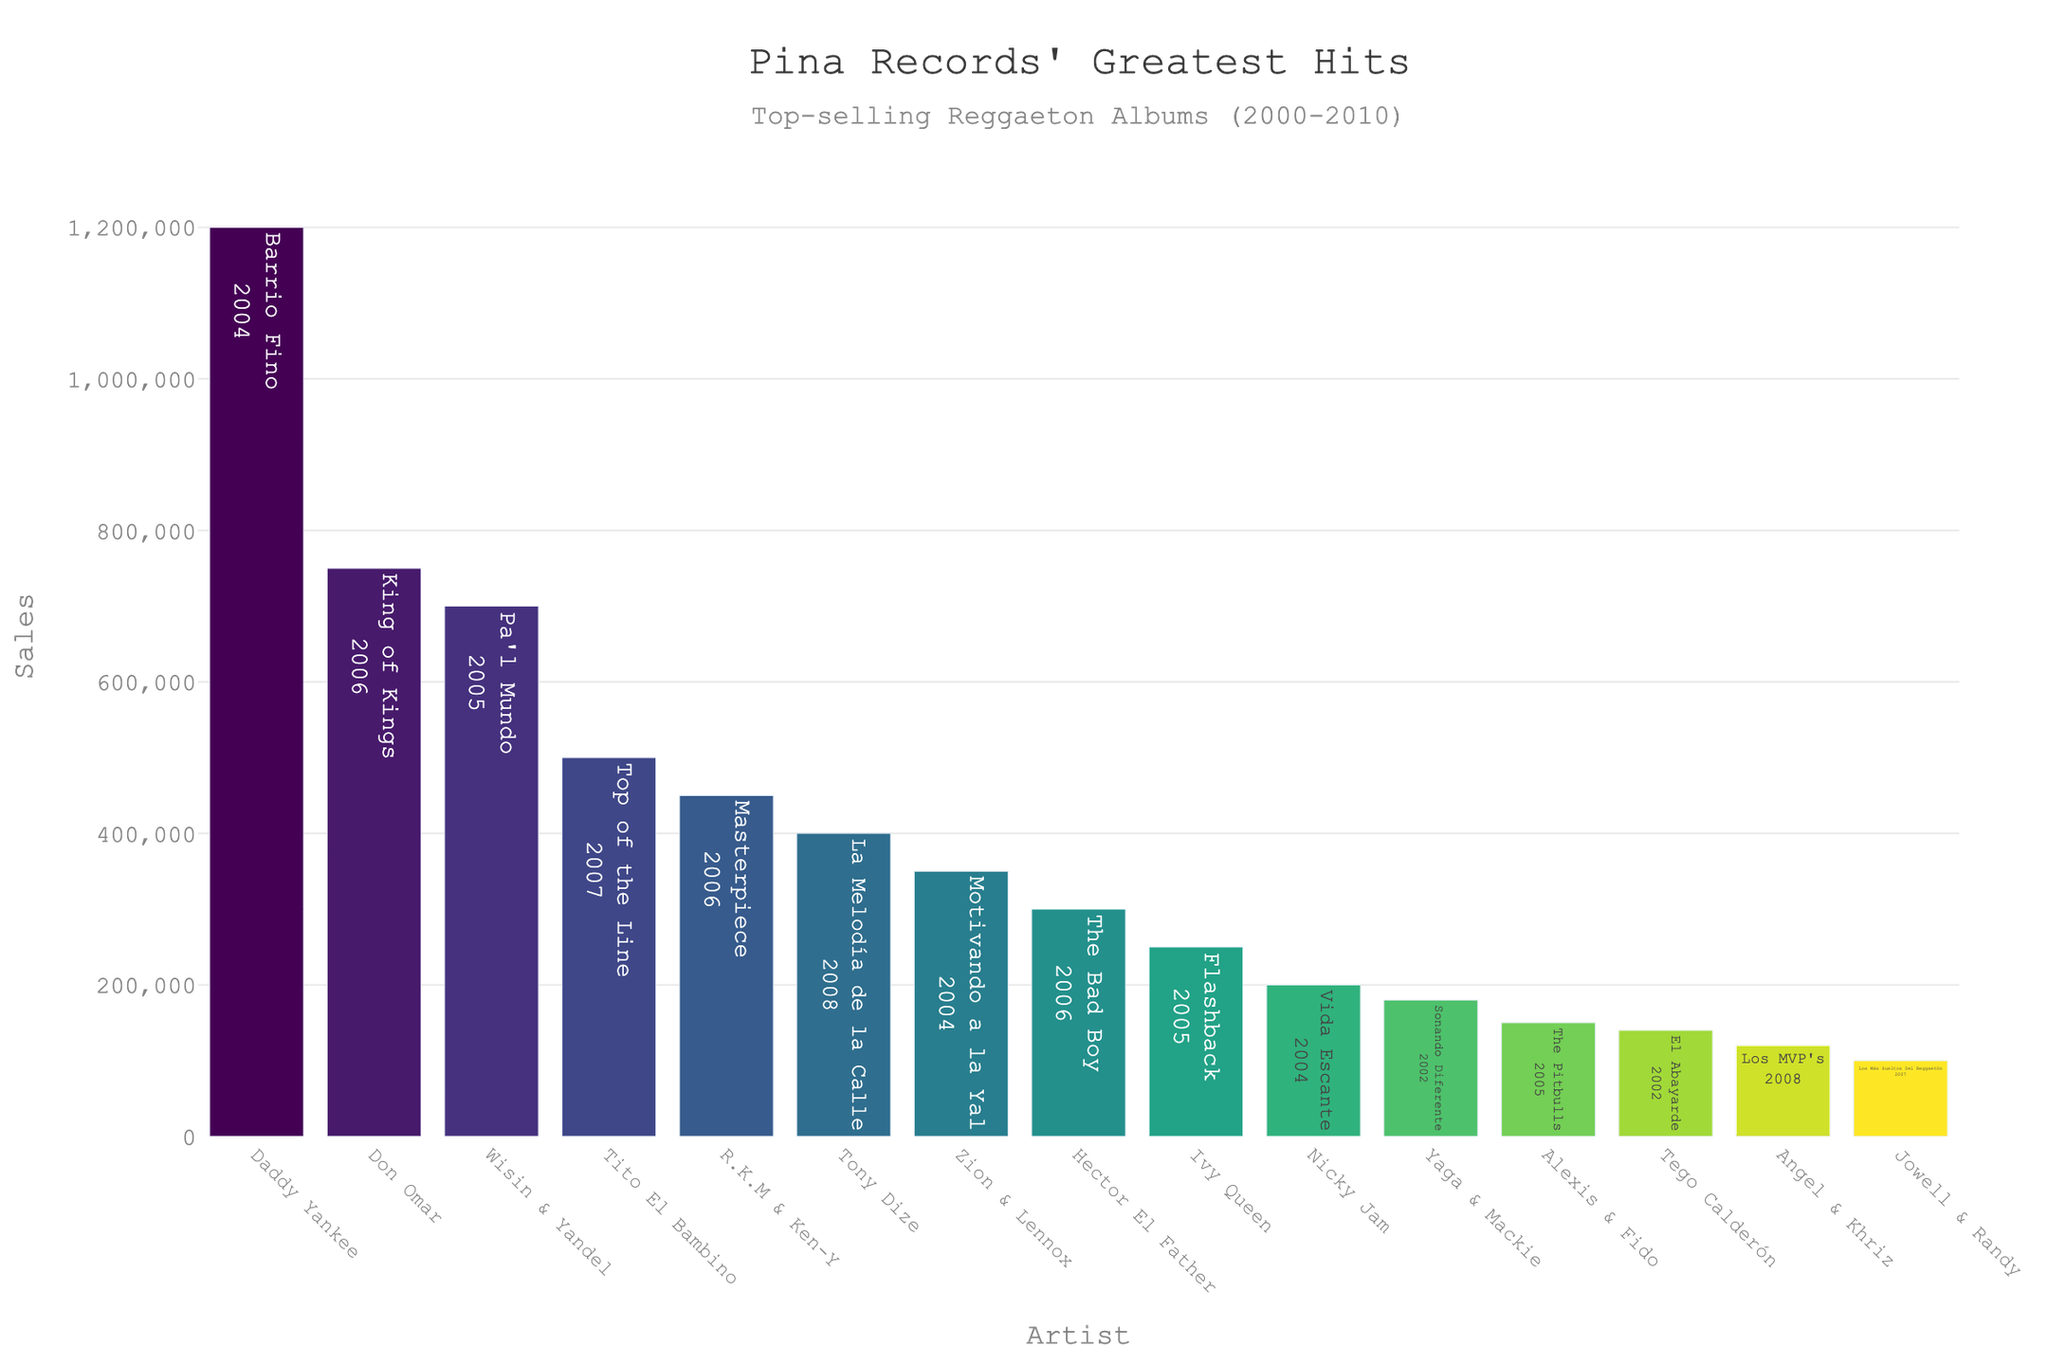Which artist has the top-selling album? The artist associated with the highest bar is Daddy Yankee with the album 'Barrio Fino'.
Answer: Daddy Yankee Which album released in 2005 sold the most copies? Among the albums released in 2005, 'Pa'l Mundo' by Wisin & Yandel has the highest bar.
Answer: Pa'l Mundo What is the total number of sales for albums released in 2006? Add the sales from albums released in 2006: 'King of Kings' (750,000) + 'Masterpiece' (450,000) + 'The Bad Boy' (300,000).
Answer: 1,500,000 Compare the sales of ‘Barrio Fino’ and ‘King of Kings’. Which one is higher and by how much? ‘Barrio Fino’ (1,200,000) has higher sales than ‘King of Kings’ (750,000). The difference is 1,200,000 - 750,000.
Answer: Barrio Fino by 450,000 What is the average sales figure for albums produced in 2007? There are two albums from 2007: 'Top of the Line' (500,000) and 'Los Más Sueltos Del Reggaetón' (100,000). The average is (500,000 + 100,000)/2.
Answer: 300,000 Which artist had the lowest sales for their album? The shortest bar on the chart corresponds to 'Los MVP's' by Angel & Khriz.
Answer: Angel & Khriz How many albums sold more than 500,000 copies? The albums with sales bars taller than 500,000 are: 'Barrio Fino' (1,200,000), 'King of Kings' (750,000), and 'Pa'l Mundo' (700,000).
Answer: 3 What was the total sales for albums released in 2004? Sum the sales of albums released in 2004: 'Barrio Fino' (1,200,000), 'Motivando a la Yal' (350,000), and 'Vida Escante' (200,000).
Answer: 1,750,000 Which album released by Wisin & Yandel sold the most copies? Wisin & Yandel have one album in the chart, 'Pa'l Mundo', which sold 700,000 copies.
Answer: Pa'l Mundo What is the average sales for albums in the top 5 best-selling list? The top 5 albums are 'Barrio Fino' (1,200,000), 'King of Kings' (750,000), 'Pa'l Mundo' (700,000), 'Top of the Line' (500,000), and 'Masterpiece' (450,000). The average is (1,200,000 + 750,000 + 700,000 + 500,000 + 450,000)/5.
Answer: 720,000 